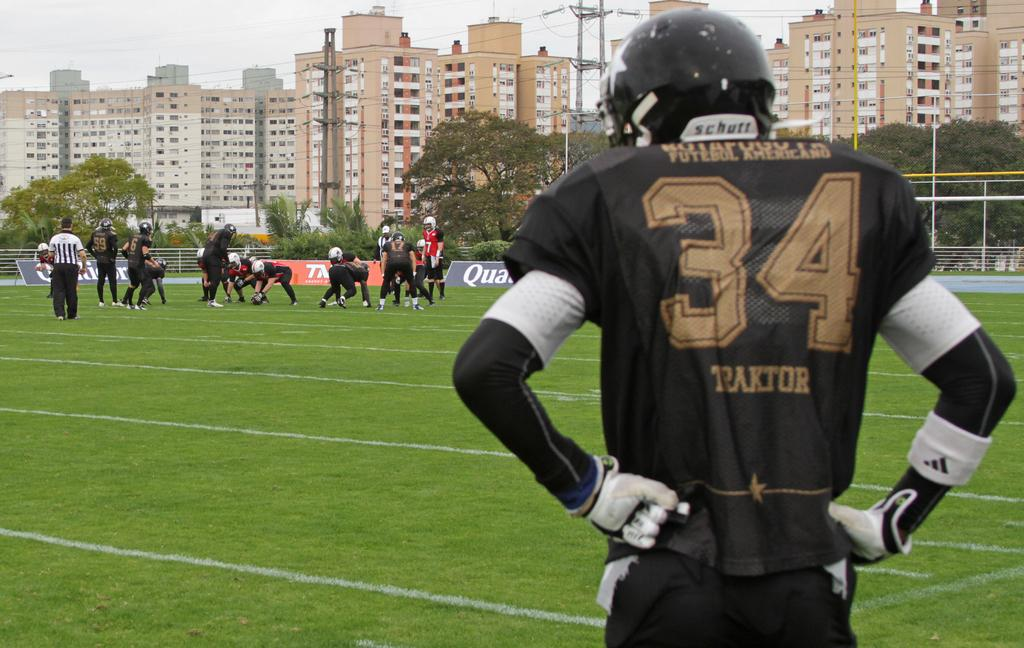What activity are the people in the image engaged in? The people in the image are playing a game. Where is the game being played? The game is being played on the grass. What can be seen in the background of the image? There are trees, buildings, poles, and wires visible in the background of the image. What is visible at the top of the image? The sky is visible at the top of the image. What type of letters are the people playing with in the image? There are no letters present in the image; the people are playing a game on the grass. How many cows can be seen grazing in the background of the image? There are no cows present in the image; the background features trees, buildings, poles, and wires. 